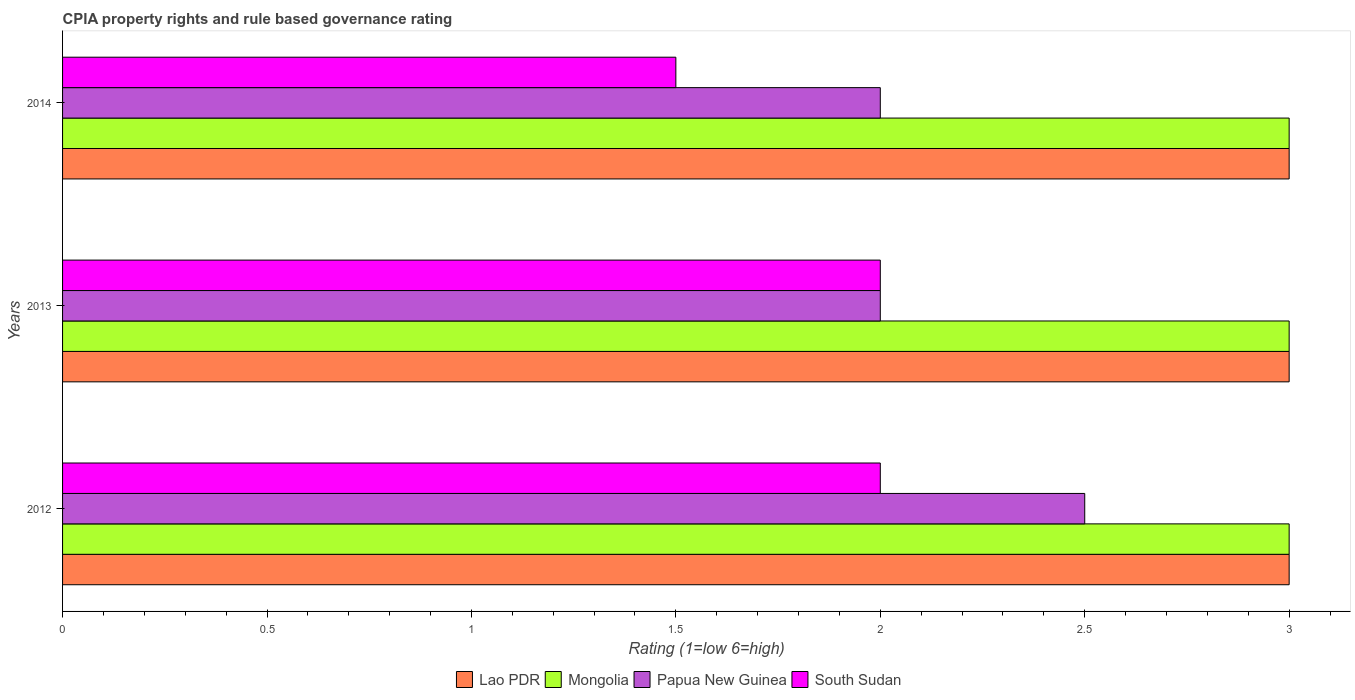How many different coloured bars are there?
Provide a succinct answer. 4. How many groups of bars are there?
Offer a terse response. 3. Are the number of bars per tick equal to the number of legend labels?
Ensure brevity in your answer.  Yes. Are the number of bars on each tick of the Y-axis equal?
Offer a very short reply. Yes. How many bars are there on the 3rd tick from the top?
Give a very brief answer. 4. What is the label of the 2nd group of bars from the top?
Your answer should be compact. 2013. What is the CPIA rating in Lao PDR in 2012?
Give a very brief answer. 3. Across all years, what is the minimum CPIA rating in Papua New Guinea?
Your answer should be very brief. 2. What is the total CPIA rating in South Sudan in the graph?
Give a very brief answer. 5.5. What is the difference between the CPIA rating in Mongolia in 2013 and that in 2014?
Provide a short and direct response. 0. What is the average CPIA rating in Mongolia per year?
Make the answer very short. 3. In the year 2014, what is the difference between the CPIA rating in South Sudan and CPIA rating in Papua New Guinea?
Provide a succinct answer. -0.5. In how many years, is the CPIA rating in South Sudan greater than 1 ?
Your answer should be compact. 3. What is the ratio of the CPIA rating in Mongolia in 2013 to that in 2014?
Your answer should be very brief. 1. Is the sum of the CPIA rating in Lao PDR in 2012 and 2013 greater than the maximum CPIA rating in South Sudan across all years?
Make the answer very short. Yes. Is it the case that in every year, the sum of the CPIA rating in Mongolia and CPIA rating in Lao PDR is greater than the sum of CPIA rating in South Sudan and CPIA rating in Papua New Guinea?
Offer a very short reply. Yes. What does the 1st bar from the top in 2012 represents?
Ensure brevity in your answer.  South Sudan. What does the 2nd bar from the bottom in 2014 represents?
Make the answer very short. Mongolia. How many bars are there?
Give a very brief answer. 12. Are the values on the major ticks of X-axis written in scientific E-notation?
Provide a short and direct response. No. Does the graph contain grids?
Provide a succinct answer. No. How many legend labels are there?
Make the answer very short. 4. How are the legend labels stacked?
Your answer should be very brief. Horizontal. What is the title of the graph?
Make the answer very short. CPIA property rights and rule based governance rating. Does "Tanzania" appear as one of the legend labels in the graph?
Offer a very short reply. No. What is the label or title of the X-axis?
Your answer should be compact. Rating (1=low 6=high). What is the Rating (1=low 6=high) of Mongolia in 2012?
Keep it short and to the point. 3. What is the Rating (1=low 6=high) in Papua New Guinea in 2012?
Make the answer very short. 2.5. What is the Rating (1=low 6=high) of South Sudan in 2012?
Offer a terse response. 2. What is the Rating (1=low 6=high) of Lao PDR in 2014?
Keep it short and to the point. 3. What is the Rating (1=low 6=high) of Papua New Guinea in 2014?
Keep it short and to the point. 2. What is the Rating (1=low 6=high) in South Sudan in 2014?
Provide a short and direct response. 1.5. Across all years, what is the maximum Rating (1=low 6=high) in Mongolia?
Offer a very short reply. 3. Across all years, what is the maximum Rating (1=low 6=high) in South Sudan?
Make the answer very short. 2. Across all years, what is the minimum Rating (1=low 6=high) of Lao PDR?
Make the answer very short. 3. Across all years, what is the minimum Rating (1=low 6=high) in South Sudan?
Give a very brief answer. 1.5. What is the total Rating (1=low 6=high) in Lao PDR in the graph?
Ensure brevity in your answer.  9. What is the total Rating (1=low 6=high) of Papua New Guinea in the graph?
Ensure brevity in your answer.  6.5. What is the total Rating (1=low 6=high) of South Sudan in the graph?
Provide a short and direct response. 5.5. What is the difference between the Rating (1=low 6=high) in Lao PDR in 2012 and that in 2013?
Make the answer very short. 0. What is the difference between the Rating (1=low 6=high) of South Sudan in 2012 and that in 2013?
Offer a very short reply. 0. What is the difference between the Rating (1=low 6=high) of Mongolia in 2012 and that in 2014?
Provide a succinct answer. 0. What is the difference between the Rating (1=low 6=high) in Papua New Guinea in 2012 and that in 2014?
Give a very brief answer. 0.5. What is the difference between the Rating (1=low 6=high) in South Sudan in 2012 and that in 2014?
Provide a short and direct response. 0.5. What is the difference between the Rating (1=low 6=high) of Lao PDR in 2013 and that in 2014?
Give a very brief answer. 0. What is the difference between the Rating (1=low 6=high) of Mongolia in 2013 and that in 2014?
Ensure brevity in your answer.  0. What is the difference between the Rating (1=low 6=high) of Papua New Guinea in 2013 and that in 2014?
Your answer should be very brief. 0. What is the difference between the Rating (1=low 6=high) in Mongolia in 2012 and the Rating (1=low 6=high) in South Sudan in 2013?
Keep it short and to the point. 1. What is the difference between the Rating (1=low 6=high) of Lao PDR in 2012 and the Rating (1=low 6=high) of Mongolia in 2014?
Offer a very short reply. 0. What is the difference between the Rating (1=low 6=high) in Lao PDR in 2012 and the Rating (1=low 6=high) in South Sudan in 2014?
Give a very brief answer. 1.5. What is the difference between the Rating (1=low 6=high) in Mongolia in 2012 and the Rating (1=low 6=high) in Papua New Guinea in 2014?
Your response must be concise. 1. What is the difference between the Rating (1=low 6=high) of Mongolia in 2012 and the Rating (1=low 6=high) of South Sudan in 2014?
Make the answer very short. 1.5. What is the difference between the Rating (1=low 6=high) in Papua New Guinea in 2012 and the Rating (1=low 6=high) in South Sudan in 2014?
Give a very brief answer. 1. What is the difference between the Rating (1=low 6=high) in Lao PDR in 2013 and the Rating (1=low 6=high) in Papua New Guinea in 2014?
Your answer should be very brief. 1. What is the difference between the Rating (1=low 6=high) in Mongolia in 2013 and the Rating (1=low 6=high) in Papua New Guinea in 2014?
Provide a short and direct response. 1. What is the difference between the Rating (1=low 6=high) of Mongolia in 2013 and the Rating (1=low 6=high) of South Sudan in 2014?
Ensure brevity in your answer.  1.5. What is the difference between the Rating (1=low 6=high) in Papua New Guinea in 2013 and the Rating (1=low 6=high) in South Sudan in 2014?
Keep it short and to the point. 0.5. What is the average Rating (1=low 6=high) in Papua New Guinea per year?
Ensure brevity in your answer.  2.17. What is the average Rating (1=low 6=high) of South Sudan per year?
Make the answer very short. 1.83. In the year 2012, what is the difference between the Rating (1=low 6=high) in Lao PDR and Rating (1=low 6=high) in Mongolia?
Ensure brevity in your answer.  0. In the year 2012, what is the difference between the Rating (1=low 6=high) of Lao PDR and Rating (1=low 6=high) of Papua New Guinea?
Provide a succinct answer. 0.5. In the year 2012, what is the difference between the Rating (1=low 6=high) in Papua New Guinea and Rating (1=low 6=high) in South Sudan?
Make the answer very short. 0.5. In the year 2013, what is the difference between the Rating (1=low 6=high) of Lao PDR and Rating (1=low 6=high) of Mongolia?
Provide a short and direct response. 0. In the year 2013, what is the difference between the Rating (1=low 6=high) of Lao PDR and Rating (1=low 6=high) of South Sudan?
Provide a short and direct response. 1. In the year 2013, what is the difference between the Rating (1=low 6=high) in Mongolia and Rating (1=low 6=high) in Papua New Guinea?
Your answer should be very brief. 1. In the year 2013, what is the difference between the Rating (1=low 6=high) in Papua New Guinea and Rating (1=low 6=high) in South Sudan?
Give a very brief answer. 0. In the year 2014, what is the difference between the Rating (1=low 6=high) in Lao PDR and Rating (1=low 6=high) in Papua New Guinea?
Offer a terse response. 1. In the year 2014, what is the difference between the Rating (1=low 6=high) of Mongolia and Rating (1=low 6=high) of Papua New Guinea?
Offer a terse response. 1. What is the ratio of the Rating (1=low 6=high) in Lao PDR in 2012 to that in 2013?
Provide a succinct answer. 1. What is the ratio of the Rating (1=low 6=high) in Papua New Guinea in 2012 to that in 2013?
Make the answer very short. 1.25. What is the ratio of the Rating (1=low 6=high) of Lao PDR in 2012 to that in 2014?
Your response must be concise. 1. What is the ratio of the Rating (1=low 6=high) of Mongolia in 2012 to that in 2014?
Give a very brief answer. 1. What is the ratio of the Rating (1=low 6=high) in Papua New Guinea in 2012 to that in 2014?
Make the answer very short. 1.25. What is the ratio of the Rating (1=low 6=high) of South Sudan in 2012 to that in 2014?
Your response must be concise. 1.33. What is the ratio of the Rating (1=low 6=high) of South Sudan in 2013 to that in 2014?
Your answer should be very brief. 1.33. What is the difference between the highest and the second highest Rating (1=low 6=high) of Mongolia?
Make the answer very short. 0. 